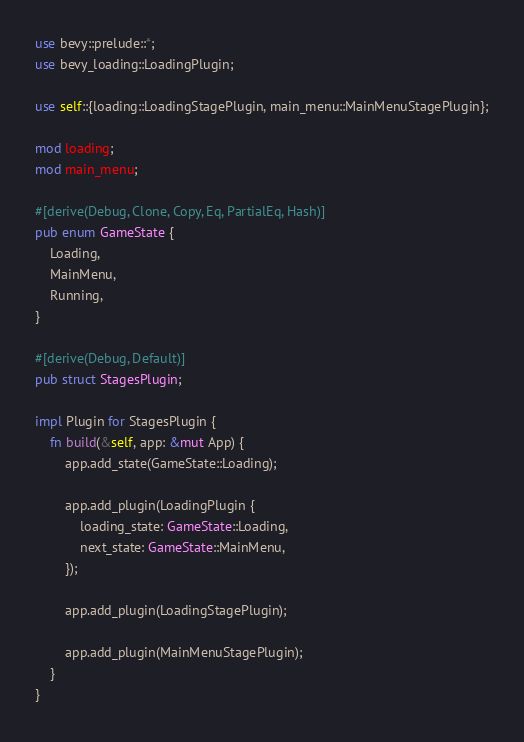Convert code to text. <code><loc_0><loc_0><loc_500><loc_500><_Rust_>use bevy::prelude::*;
use bevy_loading::LoadingPlugin;

use self::{loading::LoadingStagePlugin, main_menu::MainMenuStagePlugin};

mod loading;
mod main_menu;

#[derive(Debug, Clone, Copy, Eq, PartialEq, Hash)]
pub enum GameState {
    Loading,
    MainMenu,
    Running,
}

#[derive(Debug, Default)]
pub struct StagesPlugin;

impl Plugin for StagesPlugin {
    fn build(&self, app: &mut App) {
        app.add_state(GameState::Loading);

        app.add_plugin(LoadingPlugin {
            loading_state: GameState::Loading,
            next_state: GameState::MainMenu,
        });

        app.add_plugin(LoadingStagePlugin);

        app.add_plugin(MainMenuStagePlugin);
    }
}
</code> 